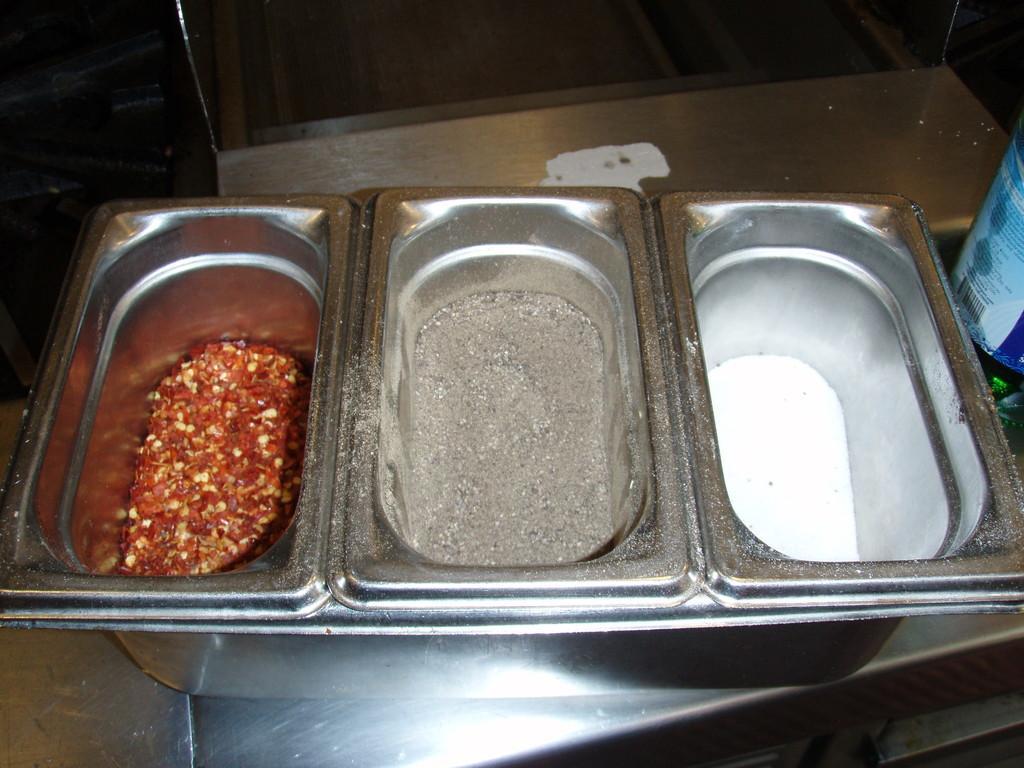Please provide a concise description of this image. In this image there are vessels on a table. In the vessels there are spices. There are chilli flakes, pepper powder and salt. To the right there is a tin on the table. 